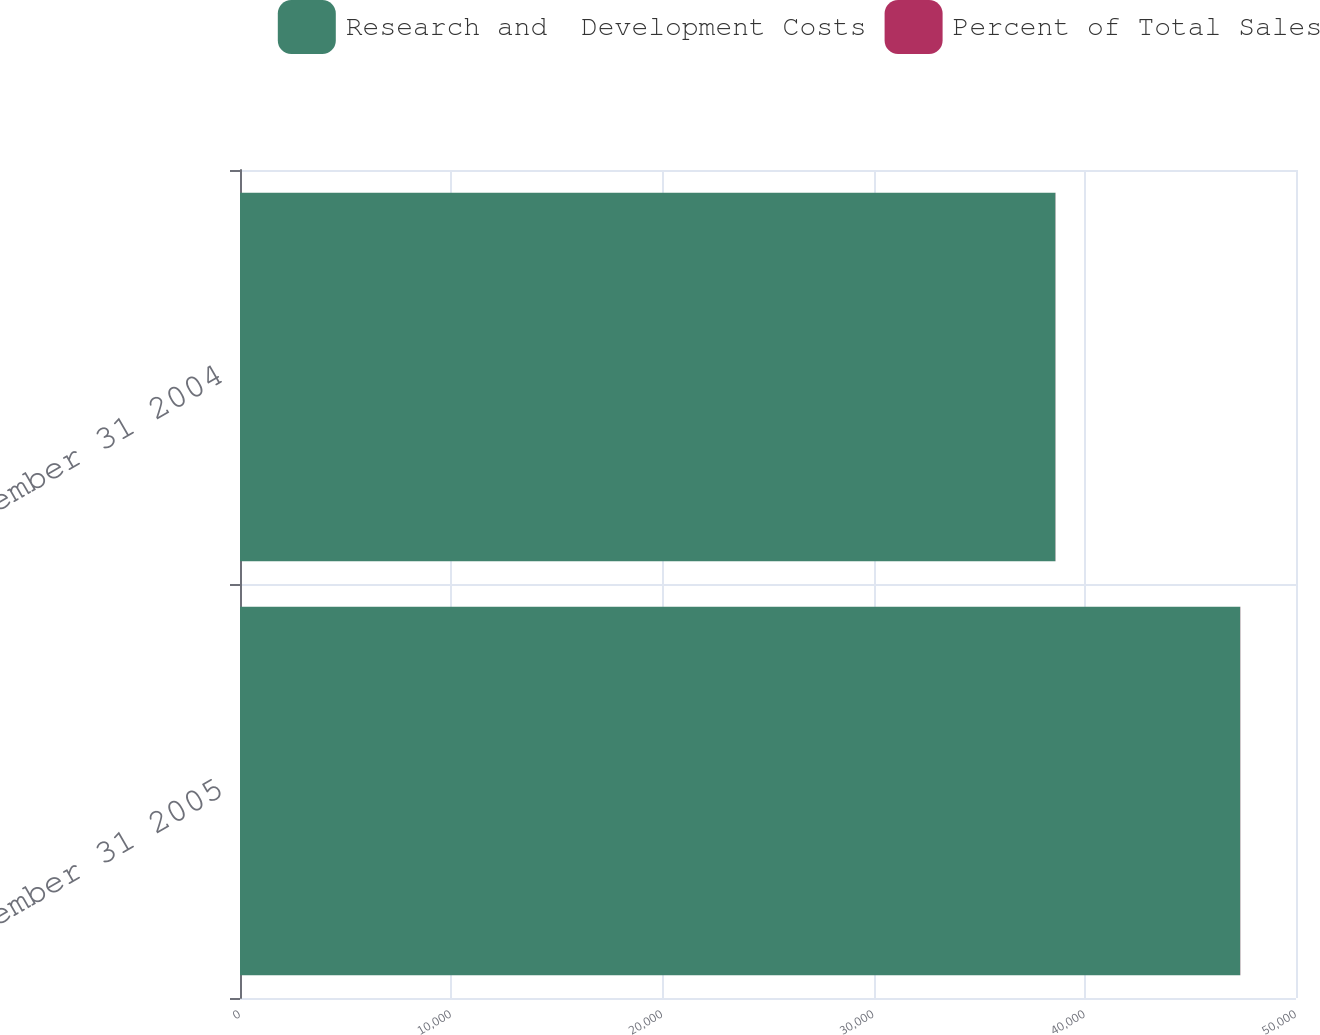Convert chart. <chart><loc_0><loc_0><loc_500><loc_500><stacked_bar_chart><ecel><fcel>December 31 2005<fcel>December 31 2004<nl><fcel>Research and  Development Costs<fcel>47359<fcel>38609<nl><fcel>Percent of Total Sales<fcel>6.7<fcel>5.8<nl></chart> 